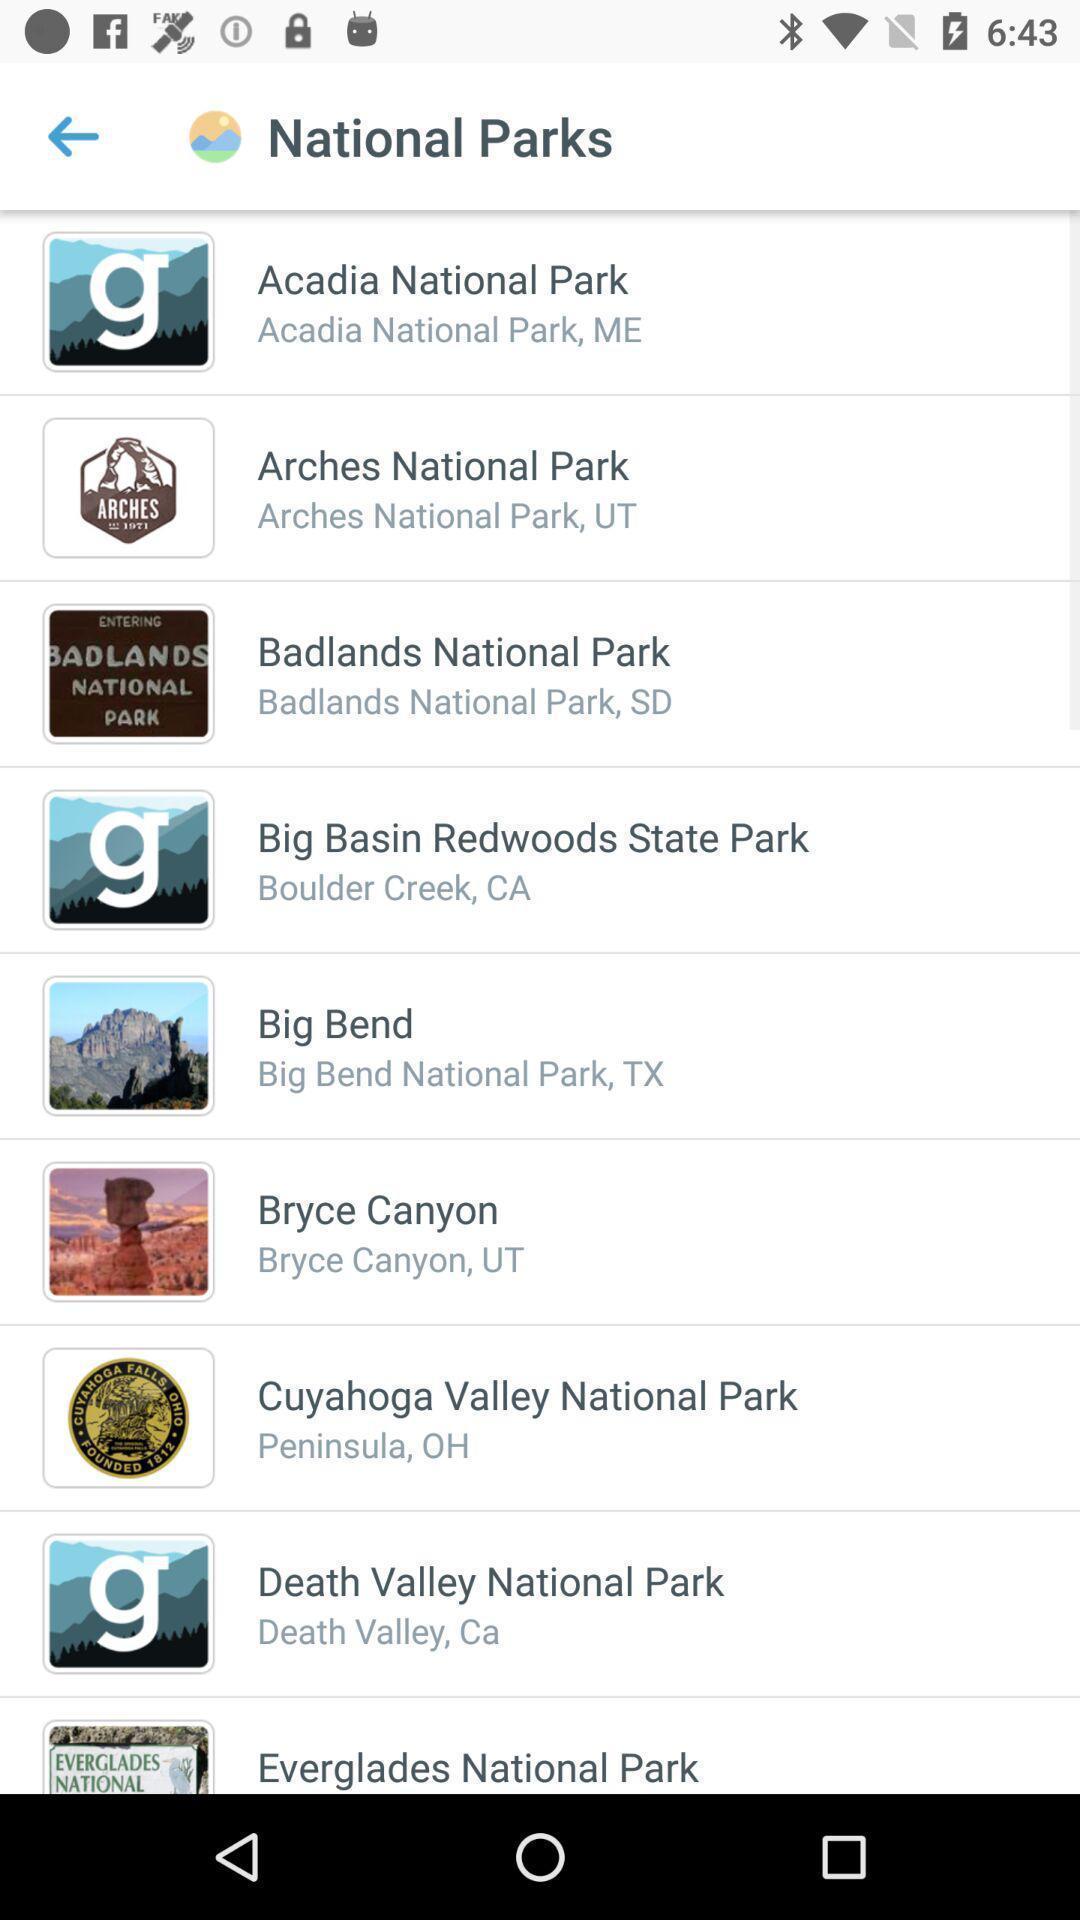Give me a narrative description of this picture. Page showing info in a local destinations app. 